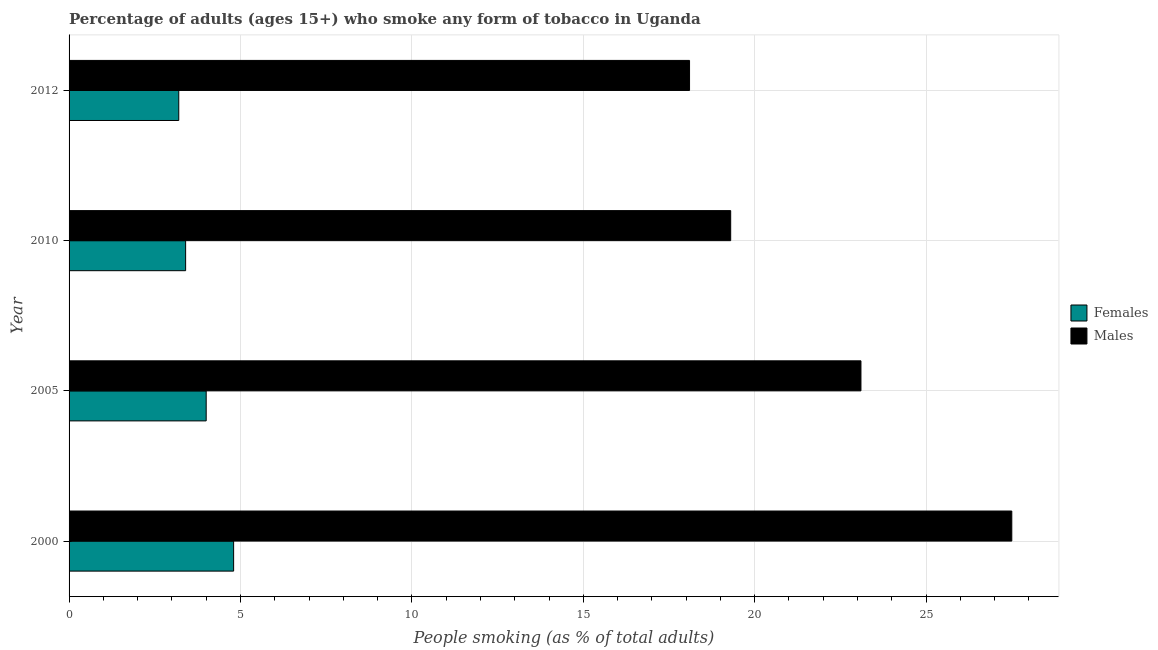Are the number of bars on each tick of the Y-axis equal?
Your answer should be very brief. Yes. What is the percentage of females who smoke in 2000?
Make the answer very short. 4.8. Across all years, what is the maximum percentage of males who smoke?
Offer a terse response. 27.5. Across all years, what is the minimum percentage of females who smoke?
Your response must be concise. 3.2. In which year was the percentage of males who smoke maximum?
Provide a short and direct response. 2000. In which year was the percentage of males who smoke minimum?
Offer a terse response. 2012. What is the total percentage of females who smoke in the graph?
Your answer should be compact. 15.4. What is the difference between the percentage of females who smoke in 2005 and the percentage of males who smoke in 2012?
Give a very brief answer. -14.1. What is the average percentage of females who smoke per year?
Your answer should be very brief. 3.85. In the year 2000, what is the difference between the percentage of males who smoke and percentage of females who smoke?
Make the answer very short. 22.7. What is the ratio of the percentage of males who smoke in 2000 to that in 2012?
Provide a short and direct response. 1.52. Is the difference between the percentage of females who smoke in 2000 and 2010 greater than the difference between the percentage of males who smoke in 2000 and 2010?
Your answer should be very brief. No. What is the difference between the highest and the second highest percentage of males who smoke?
Keep it short and to the point. 4.4. In how many years, is the percentage of males who smoke greater than the average percentage of males who smoke taken over all years?
Offer a very short reply. 2. Is the sum of the percentage of females who smoke in 2005 and 2012 greater than the maximum percentage of males who smoke across all years?
Your response must be concise. No. What does the 2nd bar from the top in 2005 represents?
Offer a terse response. Females. What does the 1st bar from the bottom in 2010 represents?
Give a very brief answer. Females. How many years are there in the graph?
Your answer should be compact. 4. Are the values on the major ticks of X-axis written in scientific E-notation?
Your response must be concise. No. Where does the legend appear in the graph?
Your response must be concise. Center right. How many legend labels are there?
Offer a terse response. 2. What is the title of the graph?
Make the answer very short. Percentage of adults (ages 15+) who smoke any form of tobacco in Uganda. What is the label or title of the X-axis?
Make the answer very short. People smoking (as % of total adults). What is the label or title of the Y-axis?
Offer a very short reply. Year. What is the People smoking (as % of total adults) of Females in 2000?
Offer a very short reply. 4.8. What is the People smoking (as % of total adults) of Males in 2000?
Make the answer very short. 27.5. What is the People smoking (as % of total adults) of Males in 2005?
Make the answer very short. 23.1. What is the People smoking (as % of total adults) in Males in 2010?
Make the answer very short. 19.3. Across all years, what is the minimum People smoking (as % of total adults) of Females?
Provide a short and direct response. 3.2. Across all years, what is the minimum People smoking (as % of total adults) of Males?
Your response must be concise. 18.1. What is the total People smoking (as % of total adults) in Females in the graph?
Keep it short and to the point. 15.4. What is the difference between the People smoking (as % of total adults) in Females in 2000 and that in 2005?
Your answer should be compact. 0.8. What is the difference between the People smoking (as % of total adults) of Females in 2000 and that in 2010?
Make the answer very short. 1.4. What is the difference between the People smoking (as % of total adults) in Males in 2000 and that in 2010?
Your answer should be very brief. 8.2. What is the difference between the People smoking (as % of total adults) of Females in 2000 and that in 2012?
Give a very brief answer. 1.6. What is the difference between the People smoking (as % of total adults) of Males in 2000 and that in 2012?
Your answer should be compact. 9.4. What is the difference between the People smoking (as % of total adults) in Females in 2005 and that in 2012?
Your response must be concise. 0.8. What is the difference between the People smoking (as % of total adults) of Males in 2010 and that in 2012?
Offer a terse response. 1.2. What is the difference between the People smoking (as % of total adults) in Females in 2000 and the People smoking (as % of total adults) in Males in 2005?
Provide a short and direct response. -18.3. What is the difference between the People smoking (as % of total adults) in Females in 2000 and the People smoking (as % of total adults) in Males in 2012?
Ensure brevity in your answer.  -13.3. What is the difference between the People smoking (as % of total adults) of Females in 2005 and the People smoking (as % of total adults) of Males in 2010?
Give a very brief answer. -15.3. What is the difference between the People smoking (as % of total adults) of Females in 2005 and the People smoking (as % of total adults) of Males in 2012?
Provide a succinct answer. -14.1. What is the difference between the People smoking (as % of total adults) of Females in 2010 and the People smoking (as % of total adults) of Males in 2012?
Your answer should be very brief. -14.7. What is the average People smoking (as % of total adults) in Females per year?
Provide a succinct answer. 3.85. In the year 2000, what is the difference between the People smoking (as % of total adults) in Females and People smoking (as % of total adults) in Males?
Your response must be concise. -22.7. In the year 2005, what is the difference between the People smoking (as % of total adults) of Females and People smoking (as % of total adults) of Males?
Your answer should be very brief. -19.1. In the year 2010, what is the difference between the People smoking (as % of total adults) in Females and People smoking (as % of total adults) in Males?
Make the answer very short. -15.9. In the year 2012, what is the difference between the People smoking (as % of total adults) of Females and People smoking (as % of total adults) of Males?
Your answer should be very brief. -14.9. What is the ratio of the People smoking (as % of total adults) in Females in 2000 to that in 2005?
Your response must be concise. 1.2. What is the ratio of the People smoking (as % of total adults) in Males in 2000 to that in 2005?
Provide a short and direct response. 1.19. What is the ratio of the People smoking (as % of total adults) of Females in 2000 to that in 2010?
Offer a very short reply. 1.41. What is the ratio of the People smoking (as % of total adults) in Males in 2000 to that in 2010?
Keep it short and to the point. 1.42. What is the ratio of the People smoking (as % of total adults) in Females in 2000 to that in 2012?
Offer a very short reply. 1.5. What is the ratio of the People smoking (as % of total adults) of Males in 2000 to that in 2012?
Offer a terse response. 1.52. What is the ratio of the People smoking (as % of total adults) of Females in 2005 to that in 2010?
Give a very brief answer. 1.18. What is the ratio of the People smoking (as % of total adults) in Males in 2005 to that in 2010?
Ensure brevity in your answer.  1.2. What is the ratio of the People smoking (as % of total adults) in Females in 2005 to that in 2012?
Make the answer very short. 1.25. What is the ratio of the People smoking (as % of total adults) in Males in 2005 to that in 2012?
Ensure brevity in your answer.  1.28. What is the ratio of the People smoking (as % of total adults) in Females in 2010 to that in 2012?
Make the answer very short. 1.06. What is the ratio of the People smoking (as % of total adults) in Males in 2010 to that in 2012?
Offer a terse response. 1.07. What is the difference between the highest and the second highest People smoking (as % of total adults) of Males?
Offer a very short reply. 4.4. 